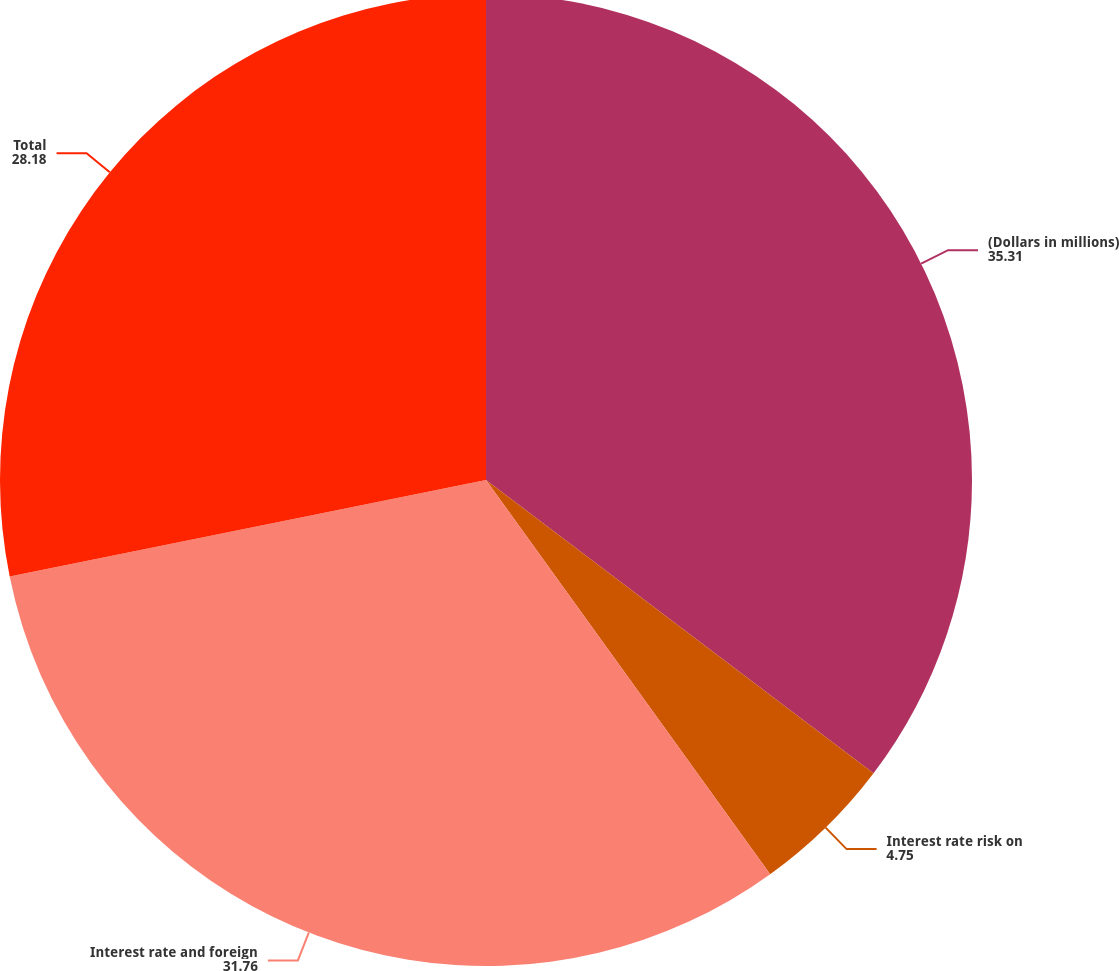Convert chart to OTSL. <chart><loc_0><loc_0><loc_500><loc_500><pie_chart><fcel>(Dollars in millions)<fcel>Interest rate risk on<fcel>Interest rate and foreign<fcel>Total<nl><fcel>35.31%<fcel>4.75%<fcel>31.76%<fcel>28.18%<nl></chart> 